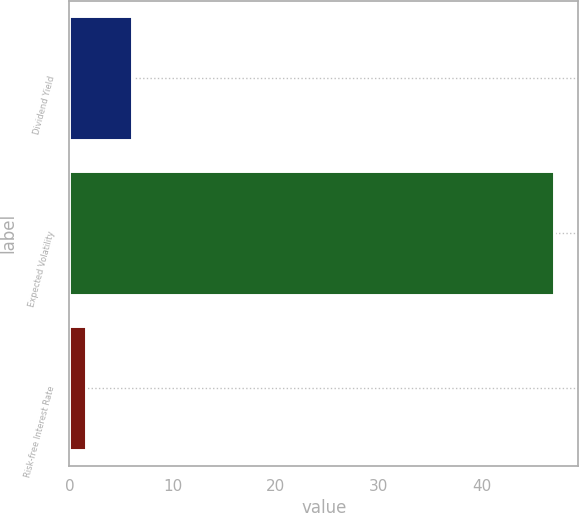Convert chart. <chart><loc_0><loc_0><loc_500><loc_500><bar_chart><fcel>Dividend Yield<fcel>Expected Volatility<fcel>Risk-free Interest Rate<nl><fcel>6.11<fcel>46.99<fcel>1.57<nl></chart> 